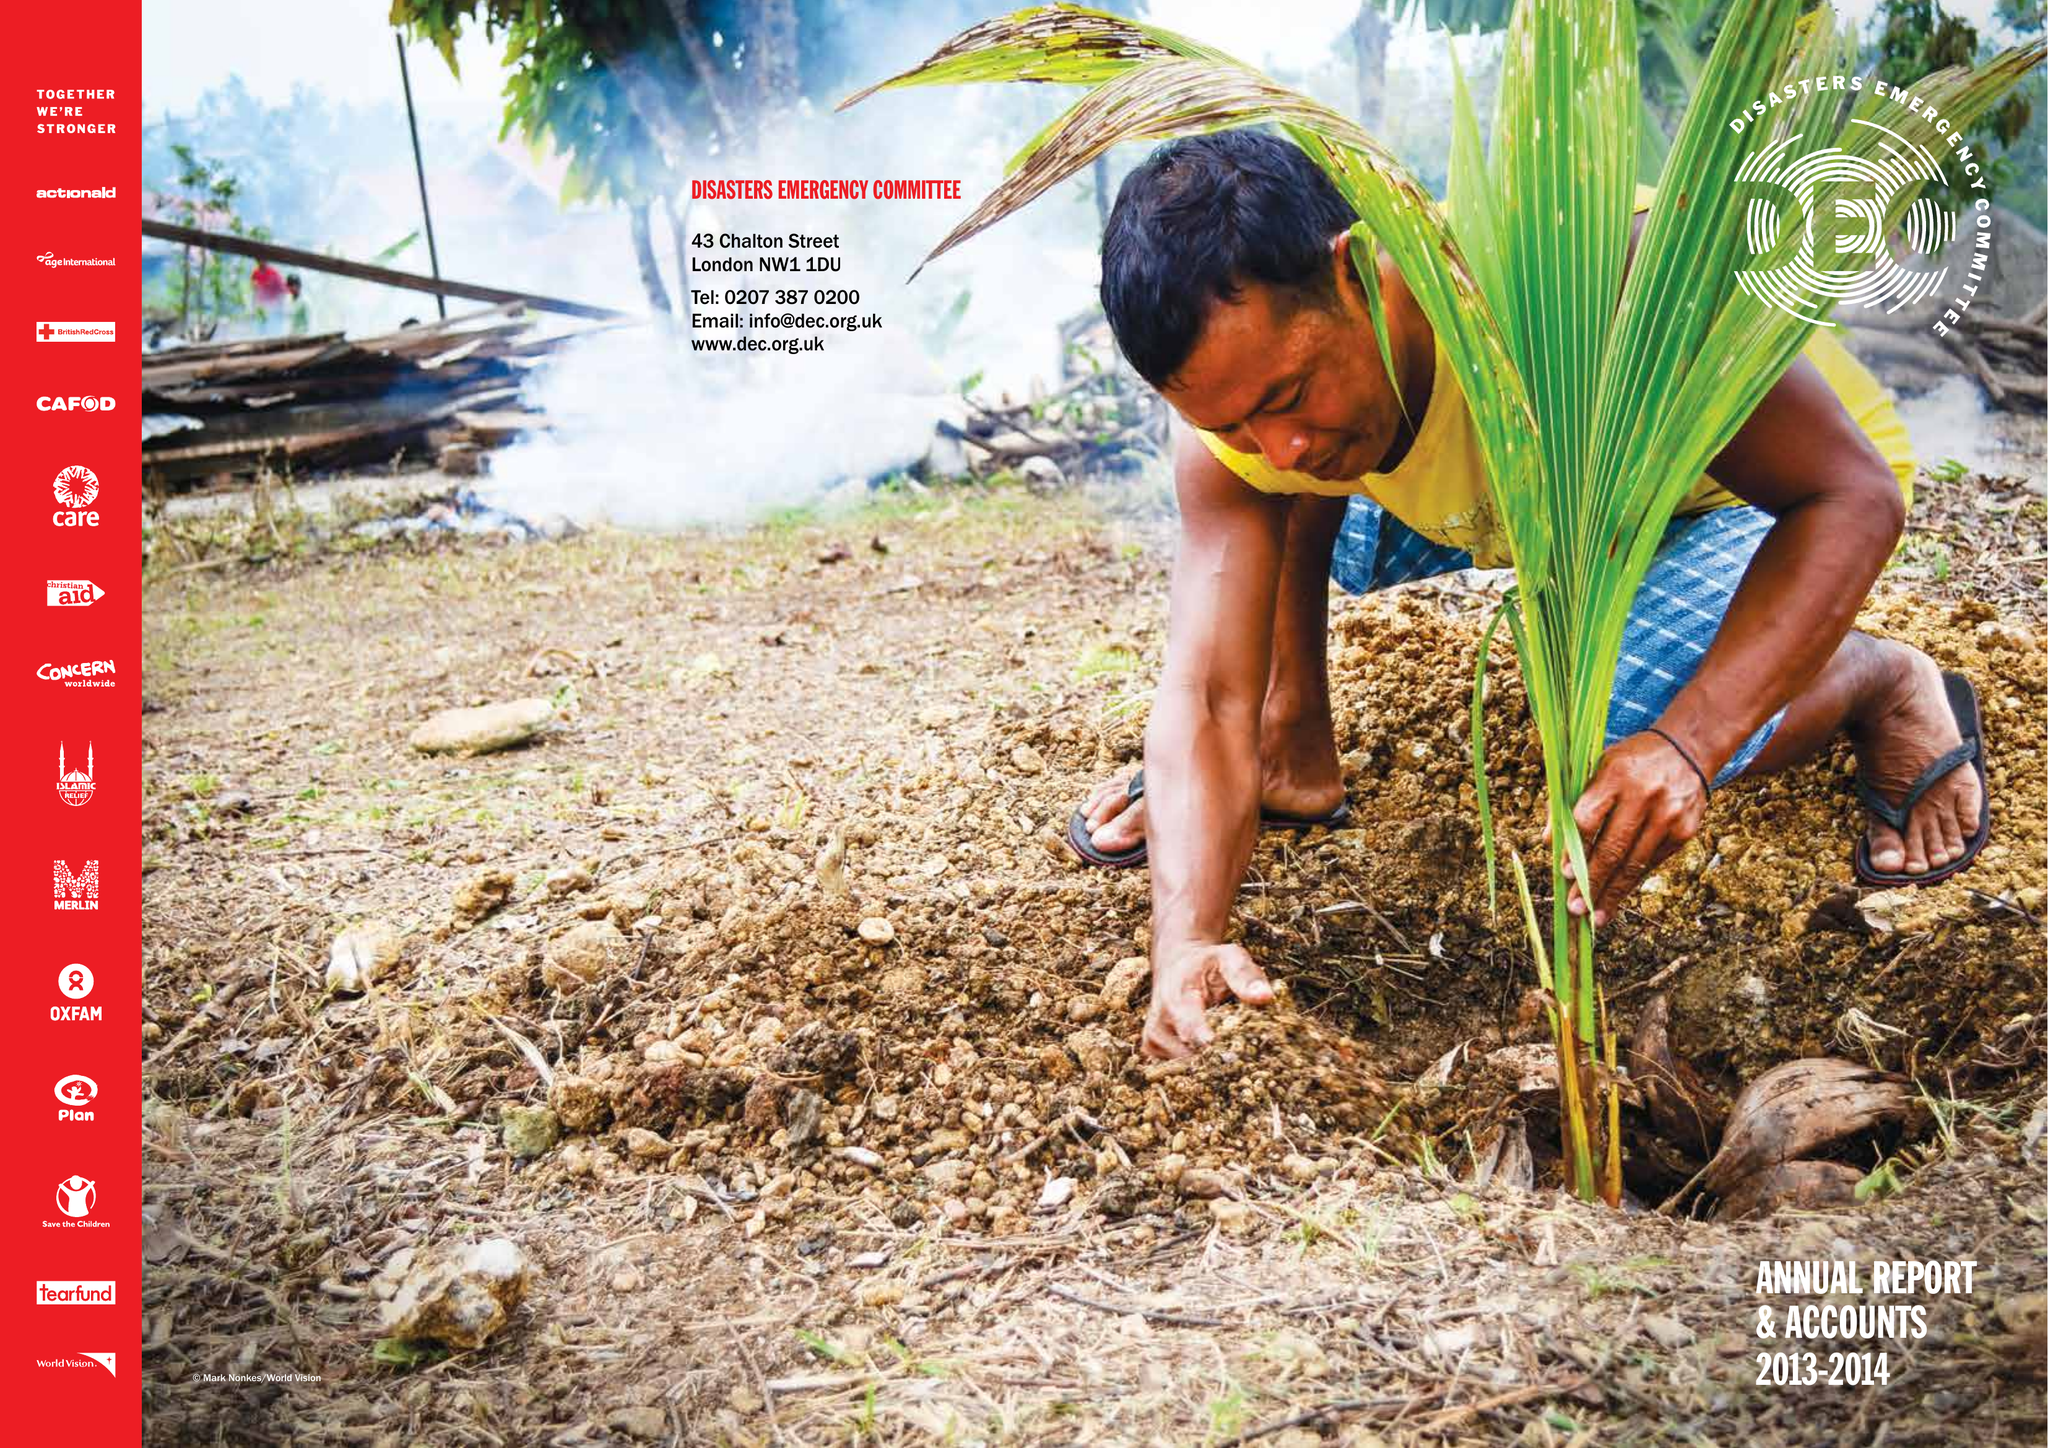What is the value for the income_annually_in_british_pounds?
Answer the question using a single word or phrase. 70028000.00 